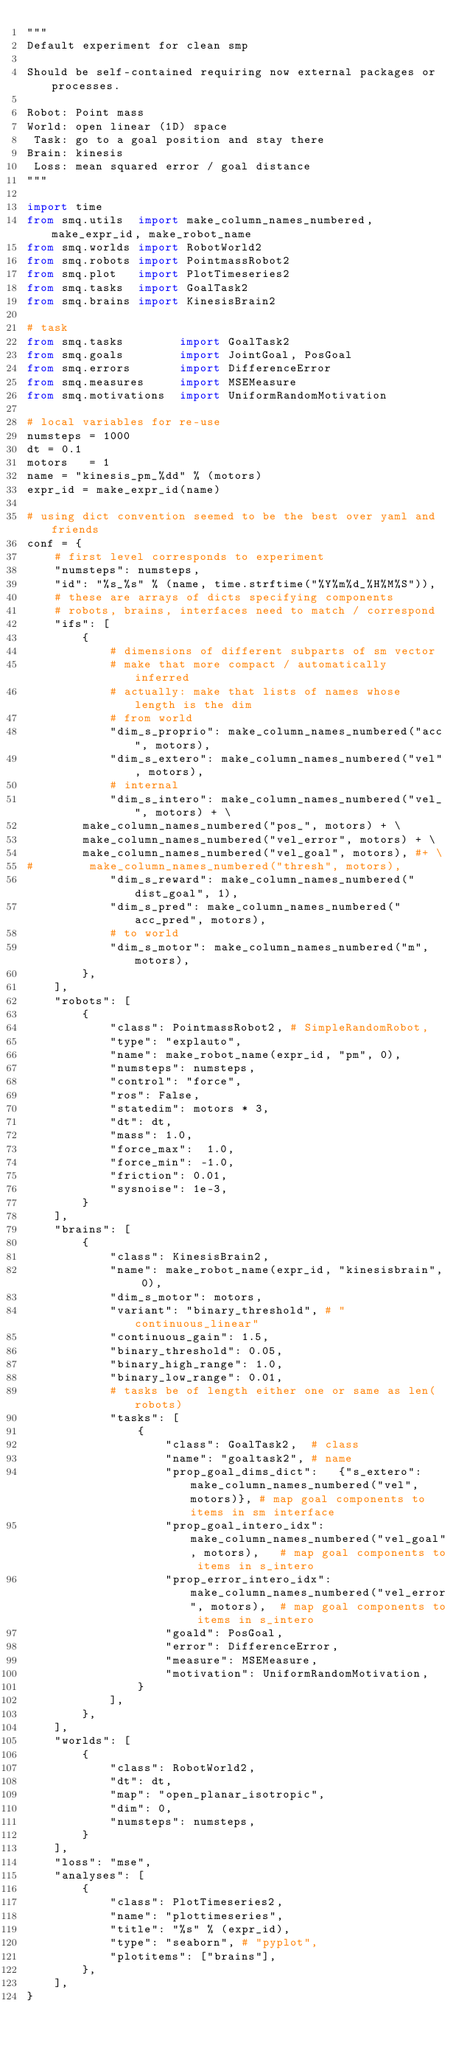<code> <loc_0><loc_0><loc_500><loc_500><_Python_>"""
Default experiment for clean smp

Should be self-contained requiring now external packages or processes.

Robot: Point mass
World: open linear (1D) space
 Task: go to a goal position and stay there
Brain: kinesis 
 Loss: mean squared error / goal distance
"""

import time
from smq.utils  import make_column_names_numbered, make_expr_id, make_robot_name
from smq.worlds import RobotWorld2
from smq.robots import PointmassRobot2
from smq.plot   import PlotTimeseries2
from smq.tasks  import GoalTask2
from smq.brains import KinesisBrain2

# task
from smq.tasks        import GoalTask2
from smq.goals        import JointGoal, PosGoal
from smq.errors       import DifferenceError
from smq.measures     import MSEMeasure
from smq.motivations  import UniformRandomMotivation

# local variables for re-use
numsteps = 1000
dt = 0.1
motors   = 1
name = "kinesis_pm_%dd" % (motors)
expr_id = make_expr_id(name)

# using dict convention seemed to be the best over yaml and friends
conf = {
    # first level corresponds to experiment
    "numsteps": numsteps,
    "id": "%s_%s" % (name, time.strftime("%Y%m%d_%H%M%S")),
    # these are arrays of dicts specifying components
    # robots, brains, interfaces need to match / correspond
    "ifs": [
        {
            # dimensions of different subparts of sm vector
            # make that more compact / automatically inferred
            # actually: make that lists of names whose length is the dim
            # from world
            "dim_s_proprio": make_column_names_numbered("acc", motors),
            "dim_s_extero": make_column_names_numbered("vel", motors),
            # internal
            "dim_s_intero": make_column_names_numbered("vel_", motors) + \
        make_column_names_numbered("pos_", motors) + \
        make_column_names_numbered("vel_error", motors) + \
        make_column_names_numbered("vel_goal", motors), #+ \
#        make_column_names_numbered("thresh", motors),
            "dim_s_reward": make_column_names_numbered("dist_goal", 1),
            "dim_s_pred": make_column_names_numbered("acc_pred", motors),
            # to world
            "dim_s_motor": make_column_names_numbered("m", motors),
        },
    ],
    "robots": [
        {
            "class": PointmassRobot2, # SimpleRandomRobot,
            "type": "explauto",
            "name": make_robot_name(expr_id, "pm", 0),
            "numsteps": numsteps,
            "control": "force",
            "ros": False,
            "statedim": motors * 3,
            "dt": dt,
            "mass": 1.0,
            "force_max":  1.0,
            "force_min": -1.0,
            "friction": 0.01,
            "sysnoise": 1e-3,
        }
    ],
    "brains": [
        {
            "class": KinesisBrain2,
            "name": make_robot_name(expr_id, "kinesisbrain", 0),
            "dim_s_motor": motors,
            "variant": "binary_threshold", # "continuous_linear"
            "continuous_gain": 1.5,
            "binary_threshold": 0.05,
            "binary_high_range": 1.0,
            "binary_low_range": 0.01,
            # tasks be of length either one or same as len(robots)
            "tasks": [
                {
                    "class": GoalTask2,  # class
                    "name": "goaltask2", # name
                    "prop_goal_dims_dict":   {"s_extero": make_column_names_numbered("vel", motors)}, # map goal components to items in sm interface
                    "prop_goal_intero_idx":  make_column_names_numbered("vel_goal", motors),   # map goal components to items in s_intero
                    "prop_error_intero_idx": make_column_names_numbered("vel_error", motors),  # map goal components to items in s_intero
                    "goald": PosGoal,
                    "error": DifferenceError,
                    "measure": MSEMeasure,
                    "motivation": UniformRandomMotivation,
                }
            ],
        },
    ],
    "worlds": [
        {
            "class": RobotWorld2,
            "dt": dt,
            "map": "open_planar_isotropic",
            "dim": 0,
            "numsteps": numsteps,
        }
    ],
    "loss": "mse",
    "analyses": [
        {
            "class": PlotTimeseries2,
            "name": "plottimeseries",
            "title": "%s" % (expr_id),
            "type": "seaborn", # "pyplot",
            "plotitems": ["brains"],
        },
    ],
}
</code> 